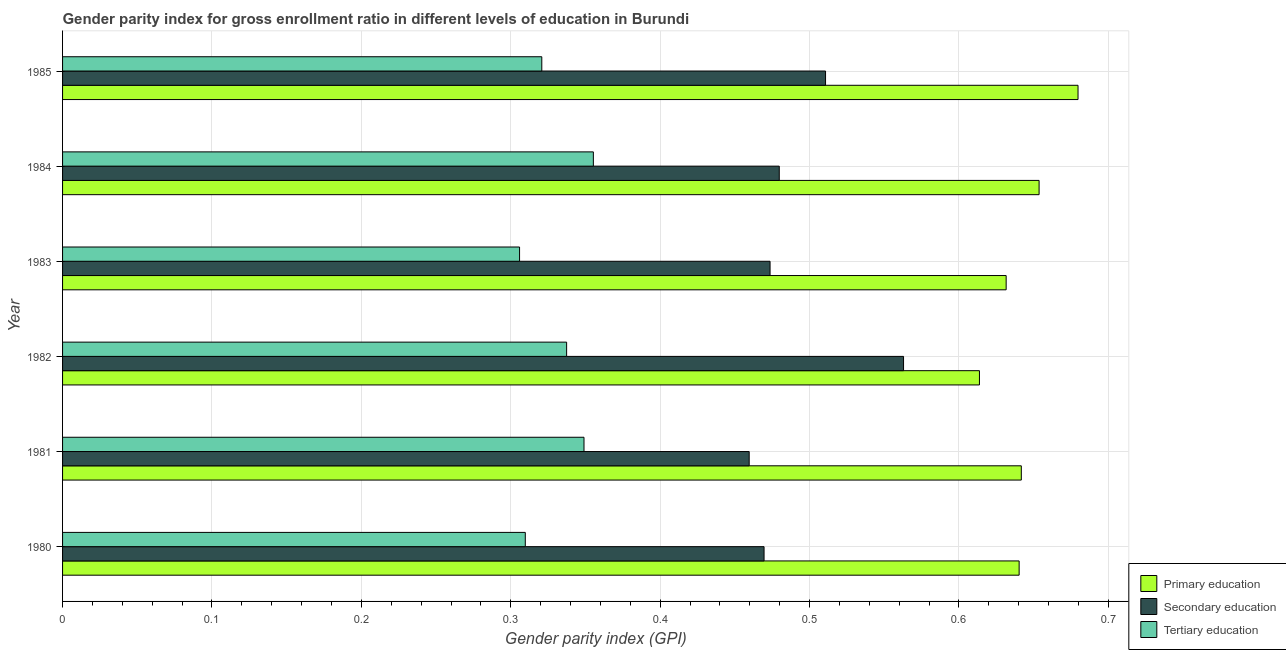Are the number of bars per tick equal to the number of legend labels?
Offer a terse response. Yes. How many bars are there on the 6th tick from the top?
Your response must be concise. 3. What is the label of the 4th group of bars from the top?
Make the answer very short. 1982. What is the gender parity index in primary education in 1982?
Your response must be concise. 0.61. Across all years, what is the maximum gender parity index in tertiary education?
Make the answer very short. 0.36. Across all years, what is the minimum gender parity index in primary education?
Give a very brief answer. 0.61. What is the total gender parity index in tertiary education in the graph?
Give a very brief answer. 1.98. What is the difference between the gender parity index in secondary education in 1980 and that in 1983?
Make the answer very short. -0. What is the difference between the gender parity index in tertiary education in 1981 and the gender parity index in secondary education in 1980?
Your answer should be compact. -0.12. What is the average gender parity index in secondary education per year?
Your response must be concise. 0.49. In the year 1980, what is the difference between the gender parity index in secondary education and gender parity index in tertiary education?
Offer a terse response. 0.16. What is the ratio of the gender parity index in tertiary education in 1981 to that in 1984?
Provide a succinct answer. 0.98. What is the difference between the highest and the second highest gender parity index in primary education?
Provide a succinct answer. 0.03. What is the difference between the highest and the lowest gender parity index in primary education?
Your answer should be very brief. 0.07. What does the 1st bar from the top in 1984 represents?
Ensure brevity in your answer.  Tertiary education. What does the 3rd bar from the bottom in 1983 represents?
Keep it short and to the point. Tertiary education. Is it the case that in every year, the sum of the gender parity index in primary education and gender parity index in secondary education is greater than the gender parity index in tertiary education?
Provide a succinct answer. Yes. Are all the bars in the graph horizontal?
Offer a terse response. Yes. How many years are there in the graph?
Offer a very short reply. 6. What is the difference between two consecutive major ticks on the X-axis?
Your answer should be very brief. 0.1. Does the graph contain grids?
Your answer should be very brief. Yes. Where does the legend appear in the graph?
Your answer should be very brief. Bottom right. How are the legend labels stacked?
Provide a short and direct response. Vertical. What is the title of the graph?
Make the answer very short. Gender parity index for gross enrollment ratio in different levels of education in Burundi. What is the label or title of the X-axis?
Your answer should be compact. Gender parity index (GPI). What is the label or title of the Y-axis?
Give a very brief answer. Year. What is the Gender parity index (GPI) of Primary education in 1980?
Offer a very short reply. 0.64. What is the Gender parity index (GPI) in Secondary education in 1980?
Provide a succinct answer. 0.47. What is the Gender parity index (GPI) of Tertiary education in 1980?
Your answer should be compact. 0.31. What is the Gender parity index (GPI) of Primary education in 1981?
Your answer should be very brief. 0.64. What is the Gender parity index (GPI) in Secondary education in 1981?
Offer a terse response. 0.46. What is the Gender parity index (GPI) of Tertiary education in 1981?
Your answer should be compact. 0.35. What is the Gender parity index (GPI) in Primary education in 1982?
Your answer should be compact. 0.61. What is the Gender parity index (GPI) in Secondary education in 1982?
Make the answer very short. 0.56. What is the Gender parity index (GPI) in Tertiary education in 1982?
Your response must be concise. 0.34. What is the Gender parity index (GPI) of Primary education in 1983?
Offer a very short reply. 0.63. What is the Gender parity index (GPI) of Secondary education in 1983?
Give a very brief answer. 0.47. What is the Gender parity index (GPI) of Tertiary education in 1983?
Your response must be concise. 0.31. What is the Gender parity index (GPI) of Primary education in 1984?
Ensure brevity in your answer.  0.65. What is the Gender parity index (GPI) of Secondary education in 1984?
Give a very brief answer. 0.48. What is the Gender parity index (GPI) of Tertiary education in 1984?
Your answer should be compact. 0.36. What is the Gender parity index (GPI) of Primary education in 1985?
Offer a terse response. 0.68. What is the Gender parity index (GPI) in Secondary education in 1985?
Keep it short and to the point. 0.51. What is the Gender parity index (GPI) of Tertiary education in 1985?
Keep it short and to the point. 0.32. Across all years, what is the maximum Gender parity index (GPI) in Primary education?
Your answer should be compact. 0.68. Across all years, what is the maximum Gender parity index (GPI) of Secondary education?
Ensure brevity in your answer.  0.56. Across all years, what is the maximum Gender parity index (GPI) of Tertiary education?
Make the answer very short. 0.36. Across all years, what is the minimum Gender parity index (GPI) of Primary education?
Your answer should be compact. 0.61. Across all years, what is the minimum Gender parity index (GPI) of Secondary education?
Make the answer very short. 0.46. Across all years, what is the minimum Gender parity index (GPI) of Tertiary education?
Your answer should be compact. 0.31. What is the total Gender parity index (GPI) of Primary education in the graph?
Ensure brevity in your answer.  3.86. What is the total Gender parity index (GPI) in Secondary education in the graph?
Offer a very short reply. 2.96. What is the total Gender parity index (GPI) of Tertiary education in the graph?
Give a very brief answer. 1.98. What is the difference between the Gender parity index (GPI) of Primary education in 1980 and that in 1981?
Offer a terse response. -0. What is the difference between the Gender parity index (GPI) of Tertiary education in 1980 and that in 1981?
Provide a succinct answer. -0.04. What is the difference between the Gender parity index (GPI) of Primary education in 1980 and that in 1982?
Your answer should be compact. 0.03. What is the difference between the Gender parity index (GPI) in Secondary education in 1980 and that in 1982?
Give a very brief answer. -0.09. What is the difference between the Gender parity index (GPI) in Tertiary education in 1980 and that in 1982?
Provide a short and direct response. -0.03. What is the difference between the Gender parity index (GPI) of Primary education in 1980 and that in 1983?
Your response must be concise. 0.01. What is the difference between the Gender parity index (GPI) in Secondary education in 1980 and that in 1983?
Your response must be concise. -0. What is the difference between the Gender parity index (GPI) in Tertiary education in 1980 and that in 1983?
Make the answer very short. 0. What is the difference between the Gender parity index (GPI) in Primary education in 1980 and that in 1984?
Ensure brevity in your answer.  -0.01. What is the difference between the Gender parity index (GPI) of Secondary education in 1980 and that in 1984?
Offer a terse response. -0.01. What is the difference between the Gender parity index (GPI) in Tertiary education in 1980 and that in 1984?
Your response must be concise. -0.05. What is the difference between the Gender parity index (GPI) of Primary education in 1980 and that in 1985?
Your answer should be compact. -0.04. What is the difference between the Gender parity index (GPI) in Secondary education in 1980 and that in 1985?
Keep it short and to the point. -0.04. What is the difference between the Gender parity index (GPI) in Tertiary education in 1980 and that in 1985?
Make the answer very short. -0.01. What is the difference between the Gender parity index (GPI) in Primary education in 1981 and that in 1982?
Your response must be concise. 0.03. What is the difference between the Gender parity index (GPI) in Secondary education in 1981 and that in 1982?
Your answer should be compact. -0.1. What is the difference between the Gender parity index (GPI) of Tertiary education in 1981 and that in 1982?
Give a very brief answer. 0.01. What is the difference between the Gender parity index (GPI) of Primary education in 1981 and that in 1983?
Provide a succinct answer. 0.01. What is the difference between the Gender parity index (GPI) of Secondary education in 1981 and that in 1983?
Provide a succinct answer. -0.01. What is the difference between the Gender parity index (GPI) in Tertiary education in 1981 and that in 1983?
Your answer should be very brief. 0.04. What is the difference between the Gender parity index (GPI) of Primary education in 1981 and that in 1984?
Give a very brief answer. -0.01. What is the difference between the Gender parity index (GPI) of Secondary education in 1981 and that in 1984?
Provide a succinct answer. -0.02. What is the difference between the Gender parity index (GPI) of Tertiary education in 1981 and that in 1984?
Provide a succinct answer. -0.01. What is the difference between the Gender parity index (GPI) in Primary education in 1981 and that in 1985?
Provide a succinct answer. -0.04. What is the difference between the Gender parity index (GPI) in Secondary education in 1981 and that in 1985?
Keep it short and to the point. -0.05. What is the difference between the Gender parity index (GPI) in Tertiary education in 1981 and that in 1985?
Offer a very short reply. 0.03. What is the difference between the Gender parity index (GPI) of Primary education in 1982 and that in 1983?
Your response must be concise. -0.02. What is the difference between the Gender parity index (GPI) in Secondary education in 1982 and that in 1983?
Ensure brevity in your answer.  0.09. What is the difference between the Gender parity index (GPI) of Tertiary education in 1982 and that in 1983?
Provide a short and direct response. 0.03. What is the difference between the Gender parity index (GPI) of Primary education in 1982 and that in 1984?
Offer a very short reply. -0.04. What is the difference between the Gender parity index (GPI) in Secondary education in 1982 and that in 1984?
Make the answer very short. 0.08. What is the difference between the Gender parity index (GPI) in Tertiary education in 1982 and that in 1984?
Your response must be concise. -0.02. What is the difference between the Gender parity index (GPI) of Primary education in 1982 and that in 1985?
Ensure brevity in your answer.  -0.07. What is the difference between the Gender parity index (GPI) in Secondary education in 1982 and that in 1985?
Your response must be concise. 0.05. What is the difference between the Gender parity index (GPI) in Tertiary education in 1982 and that in 1985?
Offer a very short reply. 0.02. What is the difference between the Gender parity index (GPI) of Primary education in 1983 and that in 1984?
Give a very brief answer. -0.02. What is the difference between the Gender parity index (GPI) of Secondary education in 1983 and that in 1984?
Your answer should be very brief. -0.01. What is the difference between the Gender parity index (GPI) of Tertiary education in 1983 and that in 1984?
Your answer should be very brief. -0.05. What is the difference between the Gender parity index (GPI) of Primary education in 1983 and that in 1985?
Make the answer very short. -0.05. What is the difference between the Gender parity index (GPI) in Secondary education in 1983 and that in 1985?
Your answer should be very brief. -0.04. What is the difference between the Gender parity index (GPI) of Tertiary education in 1983 and that in 1985?
Offer a very short reply. -0.01. What is the difference between the Gender parity index (GPI) in Primary education in 1984 and that in 1985?
Your response must be concise. -0.03. What is the difference between the Gender parity index (GPI) of Secondary education in 1984 and that in 1985?
Offer a very short reply. -0.03. What is the difference between the Gender parity index (GPI) of Tertiary education in 1984 and that in 1985?
Ensure brevity in your answer.  0.03. What is the difference between the Gender parity index (GPI) in Primary education in 1980 and the Gender parity index (GPI) in Secondary education in 1981?
Offer a very short reply. 0.18. What is the difference between the Gender parity index (GPI) of Primary education in 1980 and the Gender parity index (GPI) of Tertiary education in 1981?
Offer a very short reply. 0.29. What is the difference between the Gender parity index (GPI) of Secondary education in 1980 and the Gender parity index (GPI) of Tertiary education in 1981?
Your answer should be very brief. 0.12. What is the difference between the Gender parity index (GPI) in Primary education in 1980 and the Gender parity index (GPI) in Secondary education in 1982?
Provide a succinct answer. 0.08. What is the difference between the Gender parity index (GPI) in Primary education in 1980 and the Gender parity index (GPI) in Tertiary education in 1982?
Ensure brevity in your answer.  0.3. What is the difference between the Gender parity index (GPI) of Secondary education in 1980 and the Gender parity index (GPI) of Tertiary education in 1982?
Offer a terse response. 0.13. What is the difference between the Gender parity index (GPI) in Primary education in 1980 and the Gender parity index (GPI) in Tertiary education in 1983?
Ensure brevity in your answer.  0.33. What is the difference between the Gender parity index (GPI) in Secondary education in 1980 and the Gender parity index (GPI) in Tertiary education in 1983?
Offer a very short reply. 0.16. What is the difference between the Gender parity index (GPI) in Primary education in 1980 and the Gender parity index (GPI) in Secondary education in 1984?
Your response must be concise. 0.16. What is the difference between the Gender parity index (GPI) of Primary education in 1980 and the Gender parity index (GPI) of Tertiary education in 1984?
Offer a very short reply. 0.28. What is the difference between the Gender parity index (GPI) of Secondary education in 1980 and the Gender parity index (GPI) of Tertiary education in 1984?
Keep it short and to the point. 0.11. What is the difference between the Gender parity index (GPI) in Primary education in 1980 and the Gender parity index (GPI) in Secondary education in 1985?
Provide a short and direct response. 0.13. What is the difference between the Gender parity index (GPI) in Primary education in 1980 and the Gender parity index (GPI) in Tertiary education in 1985?
Your answer should be compact. 0.32. What is the difference between the Gender parity index (GPI) in Secondary education in 1980 and the Gender parity index (GPI) in Tertiary education in 1985?
Offer a terse response. 0.15. What is the difference between the Gender parity index (GPI) in Primary education in 1981 and the Gender parity index (GPI) in Secondary education in 1982?
Offer a very short reply. 0.08. What is the difference between the Gender parity index (GPI) in Primary education in 1981 and the Gender parity index (GPI) in Tertiary education in 1982?
Provide a short and direct response. 0.3. What is the difference between the Gender parity index (GPI) of Secondary education in 1981 and the Gender parity index (GPI) of Tertiary education in 1982?
Give a very brief answer. 0.12. What is the difference between the Gender parity index (GPI) in Primary education in 1981 and the Gender parity index (GPI) in Secondary education in 1983?
Provide a short and direct response. 0.17. What is the difference between the Gender parity index (GPI) in Primary education in 1981 and the Gender parity index (GPI) in Tertiary education in 1983?
Give a very brief answer. 0.34. What is the difference between the Gender parity index (GPI) of Secondary education in 1981 and the Gender parity index (GPI) of Tertiary education in 1983?
Your answer should be very brief. 0.15. What is the difference between the Gender parity index (GPI) in Primary education in 1981 and the Gender parity index (GPI) in Secondary education in 1984?
Make the answer very short. 0.16. What is the difference between the Gender parity index (GPI) in Primary education in 1981 and the Gender parity index (GPI) in Tertiary education in 1984?
Provide a succinct answer. 0.29. What is the difference between the Gender parity index (GPI) in Secondary education in 1981 and the Gender parity index (GPI) in Tertiary education in 1984?
Provide a succinct answer. 0.1. What is the difference between the Gender parity index (GPI) of Primary education in 1981 and the Gender parity index (GPI) of Secondary education in 1985?
Provide a succinct answer. 0.13. What is the difference between the Gender parity index (GPI) of Primary education in 1981 and the Gender parity index (GPI) of Tertiary education in 1985?
Provide a short and direct response. 0.32. What is the difference between the Gender parity index (GPI) in Secondary education in 1981 and the Gender parity index (GPI) in Tertiary education in 1985?
Offer a terse response. 0.14. What is the difference between the Gender parity index (GPI) of Primary education in 1982 and the Gender parity index (GPI) of Secondary education in 1983?
Offer a very short reply. 0.14. What is the difference between the Gender parity index (GPI) of Primary education in 1982 and the Gender parity index (GPI) of Tertiary education in 1983?
Offer a terse response. 0.31. What is the difference between the Gender parity index (GPI) in Secondary education in 1982 and the Gender parity index (GPI) in Tertiary education in 1983?
Provide a short and direct response. 0.26. What is the difference between the Gender parity index (GPI) of Primary education in 1982 and the Gender parity index (GPI) of Secondary education in 1984?
Make the answer very short. 0.13. What is the difference between the Gender parity index (GPI) of Primary education in 1982 and the Gender parity index (GPI) of Tertiary education in 1984?
Provide a succinct answer. 0.26. What is the difference between the Gender parity index (GPI) of Secondary education in 1982 and the Gender parity index (GPI) of Tertiary education in 1984?
Offer a very short reply. 0.21. What is the difference between the Gender parity index (GPI) in Primary education in 1982 and the Gender parity index (GPI) in Secondary education in 1985?
Give a very brief answer. 0.1. What is the difference between the Gender parity index (GPI) in Primary education in 1982 and the Gender parity index (GPI) in Tertiary education in 1985?
Your answer should be very brief. 0.29. What is the difference between the Gender parity index (GPI) in Secondary education in 1982 and the Gender parity index (GPI) in Tertiary education in 1985?
Your answer should be very brief. 0.24. What is the difference between the Gender parity index (GPI) in Primary education in 1983 and the Gender parity index (GPI) in Secondary education in 1984?
Provide a short and direct response. 0.15. What is the difference between the Gender parity index (GPI) of Primary education in 1983 and the Gender parity index (GPI) of Tertiary education in 1984?
Offer a very short reply. 0.28. What is the difference between the Gender parity index (GPI) in Secondary education in 1983 and the Gender parity index (GPI) in Tertiary education in 1984?
Offer a very short reply. 0.12. What is the difference between the Gender parity index (GPI) in Primary education in 1983 and the Gender parity index (GPI) in Secondary education in 1985?
Your response must be concise. 0.12. What is the difference between the Gender parity index (GPI) of Primary education in 1983 and the Gender parity index (GPI) of Tertiary education in 1985?
Make the answer very short. 0.31. What is the difference between the Gender parity index (GPI) of Secondary education in 1983 and the Gender parity index (GPI) of Tertiary education in 1985?
Offer a very short reply. 0.15. What is the difference between the Gender parity index (GPI) of Primary education in 1984 and the Gender parity index (GPI) of Secondary education in 1985?
Provide a succinct answer. 0.14. What is the difference between the Gender parity index (GPI) in Primary education in 1984 and the Gender parity index (GPI) in Tertiary education in 1985?
Ensure brevity in your answer.  0.33. What is the difference between the Gender parity index (GPI) in Secondary education in 1984 and the Gender parity index (GPI) in Tertiary education in 1985?
Offer a terse response. 0.16. What is the average Gender parity index (GPI) of Primary education per year?
Your response must be concise. 0.64. What is the average Gender parity index (GPI) of Secondary education per year?
Give a very brief answer. 0.49. What is the average Gender parity index (GPI) of Tertiary education per year?
Your answer should be very brief. 0.33. In the year 1980, what is the difference between the Gender parity index (GPI) in Primary education and Gender parity index (GPI) in Secondary education?
Provide a short and direct response. 0.17. In the year 1980, what is the difference between the Gender parity index (GPI) of Primary education and Gender parity index (GPI) of Tertiary education?
Ensure brevity in your answer.  0.33. In the year 1980, what is the difference between the Gender parity index (GPI) in Secondary education and Gender parity index (GPI) in Tertiary education?
Your answer should be compact. 0.16. In the year 1981, what is the difference between the Gender parity index (GPI) in Primary education and Gender parity index (GPI) in Secondary education?
Your response must be concise. 0.18. In the year 1981, what is the difference between the Gender parity index (GPI) in Primary education and Gender parity index (GPI) in Tertiary education?
Offer a very short reply. 0.29. In the year 1981, what is the difference between the Gender parity index (GPI) in Secondary education and Gender parity index (GPI) in Tertiary education?
Provide a short and direct response. 0.11. In the year 1982, what is the difference between the Gender parity index (GPI) in Primary education and Gender parity index (GPI) in Secondary education?
Make the answer very short. 0.05. In the year 1982, what is the difference between the Gender parity index (GPI) in Primary education and Gender parity index (GPI) in Tertiary education?
Keep it short and to the point. 0.28. In the year 1982, what is the difference between the Gender parity index (GPI) of Secondary education and Gender parity index (GPI) of Tertiary education?
Keep it short and to the point. 0.23. In the year 1983, what is the difference between the Gender parity index (GPI) in Primary education and Gender parity index (GPI) in Secondary education?
Your response must be concise. 0.16. In the year 1983, what is the difference between the Gender parity index (GPI) of Primary education and Gender parity index (GPI) of Tertiary education?
Your answer should be very brief. 0.33. In the year 1983, what is the difference between the Gender parity index (GPI) of Secondary education and Gender parity index (GPI) of Tertiary education?
Your response must be concise. 0.17. In the year 1984, what is the difference between the Gender parity index (GPI) of Primary education and Gender parity index (GPI) of Secondary education?
Keep it short and to the point. 0.17. In the year 1984, what is the difference between the Gender parity index (GPI) of Primary education and Gender parity index (GPI) of Tertiary education?
Give a very brief answer. 0.3. In the year 1984, what is the difference between the Gender parity index (GPI) of Secondary education and Gender parity index (GPI) of Tertiary education?
Provide a succinct answer. 0.12. In the year 1985, what is the difference between the Gender parity index (GPI) of Primary education and Gender parity index (GPI) of Secondary education?
Keep it short and to the point. 0.17. In the year 1985, what is the difference between the Gender parity index (GPI) in Primary education and Gender parity index (GPI) in Tertiary education?
Keep it short and to the point. 0.36. In the year 1985, what is the difference between the Gender parity index (GPI) of Secondary education and Gender parity index (GPI) of Tertiary education?
Offer a very short reply. 0.19. What is the ratio of the Gender parity index (GPI) in Secondary education in 1980 to that in 1981?
Give a very brief answer. 1.02. What is the ratio of the Gender parity index (GPI) of Tertiary education in 1980 to that in 1981?
Your answer should be compact. 0.89. What is the ratio of the Gender parity index (GPI) in Primary education in 1980 to that in 1982?
Your answer should be very brief. 1.04. What is the ratio of the Gender parity index (GPI) in Secondary education in 1980 to that in 1982?
Give a very brief answer. 0.83. What is the ratio of the Gender parity index (GPI) in Tertiary education in 1980 to that in 1982?
Give a very brief answer. 0.92. What is the ratio of the Gender parity index (GPI) in Primary education in 1980 to that in 1983?
Make the answer very short. 1.01. What is the ratio of the Gender parity index (GPI) in Secondary education in 1980 to that in 1983?
Offer a very short reply. 0.99. What is the ratio of the Gender parity index (GPI) in Tertiary education in 1980 to that in 1983?
Give a very brief answer. 1.01. What is the ratio of the Gender parity index (GPI) of Primary education in 1980 to that in 1984?
Ensure brevity in your answer.  0.98. What is the ratio of the Gender parity index (GPI) in Secondary education in 1980 to that in 1984?
Make the answer very short. 0.98. What is the ratio of the Gender parity index (GPI) in Tertiary education in 1980 to that in 1984?
Offer a terse response. 0.87. What is the ratio of the Gender parity index (GPI) of Primary education in 1980 to that in 1985?
Ensure brevity in your answer.  0.94. What is the ratio of the Gender parity index (GPI) in Secondary education in 1980 to that in 1985?
Your answer should be very brief. 0.92. What is the ratio of the Gender parity index (GPI) of Tertiary education in 1980 to that in 1985?
Offer a very short reply. 0.97. What is the ratio of the Gender parity index (GPI) of Primary education in 1981 to that in 1982?
Provide a short and direct response. 1.05. What is the ratio of the Gender parity index (GPI) in Secondary education in 1981 to that in 1982?
Make the answer very short. 0.82. What is the ratio of the Gender parity index (GPI) in Tertiary education in 1981 to that in 1982?
Keep it short and to the point. 1.03. What is the ratio of the Gender parity index (GPI) of Primary education in 1981 to that in 1983?
Your response must be concise. 1.02. What is the ratio of the Gender parity index (GPI) in Secondary education in 1981 to that in 1983?
Give a very brief answer. 0.97. What is the ratio of the Gender parity index (GPI) in Tertiary education in 1981 to that in 1983?
Your answer should be very brief. 1.14. What is the ratio of the Gender parity index (GPI) of Primary education in 1981 to that in 1984?
Offer a very short reply. 0.98. What is the ratio of the Gender parity index (GPI) of Secondary education in 1981 to that in 1984?
Keep it short and to the point. 0.96. What is the ratio of the Gender parity index (GPI) of Tertiary education in 1981 to that in 1984?
Make the answer very short. 0.98. What is the ratio of the Gender parity index (GPI) in Primary education in 1981 to that in 1985?
Offer a terse response. 0.94. What is the ratio of the Gender parity index (GPI) of Secondary education in 1981 to that in 1985?
Your response must be concise. 0.9. What is the ratio of the Gender parity index (GPI) in Tertiary education in 1981 to that in 1985?
Your answer should be very brief. 1.09. What is the ratio of the Gender parity index (GPI) in Primary education in 1982 to that in 1983?
Make the answer very short. 0.97. What is the ratio of the Gender parity index (GPI) in Secondary education in 1982 to that in 1983?
Offer a very short reply. 1.19. What is the ratio of the Gender parity index (GPI) in Tertiary education in 1982 to that in 1983?
Provide a succinct answer. 1.1. What is the ratio of the Gender parity index (GPI) in Primary education in 1982 to that in 1984?
Make the answer very short. 0.94. What is the ratio of the Gender parity index (GPI) of Secondary education in 1982 to that in 1984?
Offer a terse response. 1.17. What is the ratio of the Gender parity index (GPI) of Tertiary education in 1982 to that in 1984?
Provide a succinct answer. 0.95. What is the ratio of the Gender parity index (GPI) in Primary education in 1982 to that in 1985?
Give a very brief answer. 0.9. What is the ratio of the Gender parity index (GPI) of Secondary education in 1982 to that in 1985?
Provide a succinct answer. 1.1. What is the ratio of the Gender parity index (GPI) of Tertiary education in 1982 to that in 1985?
Your answer should be compact. 1.05. What is the ratio of the Gender parity index (GPI) in Primary education in 1983 to that in 1984?
Provide a succinct answer. 0.97. What is the ratio of the Gender parity index (GPI) in Secondary education in 1983 to that in 1984?
Provide a succinct answer. 0.99. What is the ratio of the Gender parity index (GPI) in Tertiary education in 1983 to that in 1984?
Give a very brief answer. 0.86. What is the ratio of the Gender parity index (GPI) of Primary education in 1983 to that in 1985?
Provide a short and direct response. 0.93. What is the ratio of the Gender parity index (GPI) in Secondary education in 1983 to that in 1985?
Your answer should be compact. 0.93. What is the ratio of the Gender parity index (GPI) in Tertiary education in 1983 to that in 1985?
Offer a very short reply. 0.95. What is the ratio of the Gender parity index (GPI) of Primary education in 1984 to that in 1985?
Offer a terse response. 0.96. What is the ratio of the Gender parity index (GPI) of Secondary education in 1984 to that in 1985?
Make the answer very short. 0.94. What is the ratio of the Gender parity index (GPI) of Tertiary education in 1984 to that in 1985?
Offer a terse response. 1.11. What is the difference between the highest and the second highest Gender parity index (GPI) of Primary education?
Offer a terse response. 0.03. What is the difference between the highest and the second highest Gender parity index (GPI) of Secondary education?
Your answer should be compact. 0.05. What is the difference between the highest and the second highest Gender parity index (GPI) of Tertiary education?
Keep it short and to the point. 0.01. What is the difference between the highest and the lowest Gender parity index (GPI) in Primary education?
Your answer should be compact. 0.07. What is the difference between the highest and the lowest Gender parity index (GPI) in Secondary education?
Keep it short and to the point. 0.1. What is the difference between the highest and the lowest Gender parity index (GPI) of Tertiary education?
Make the answer very short. 0.05. 